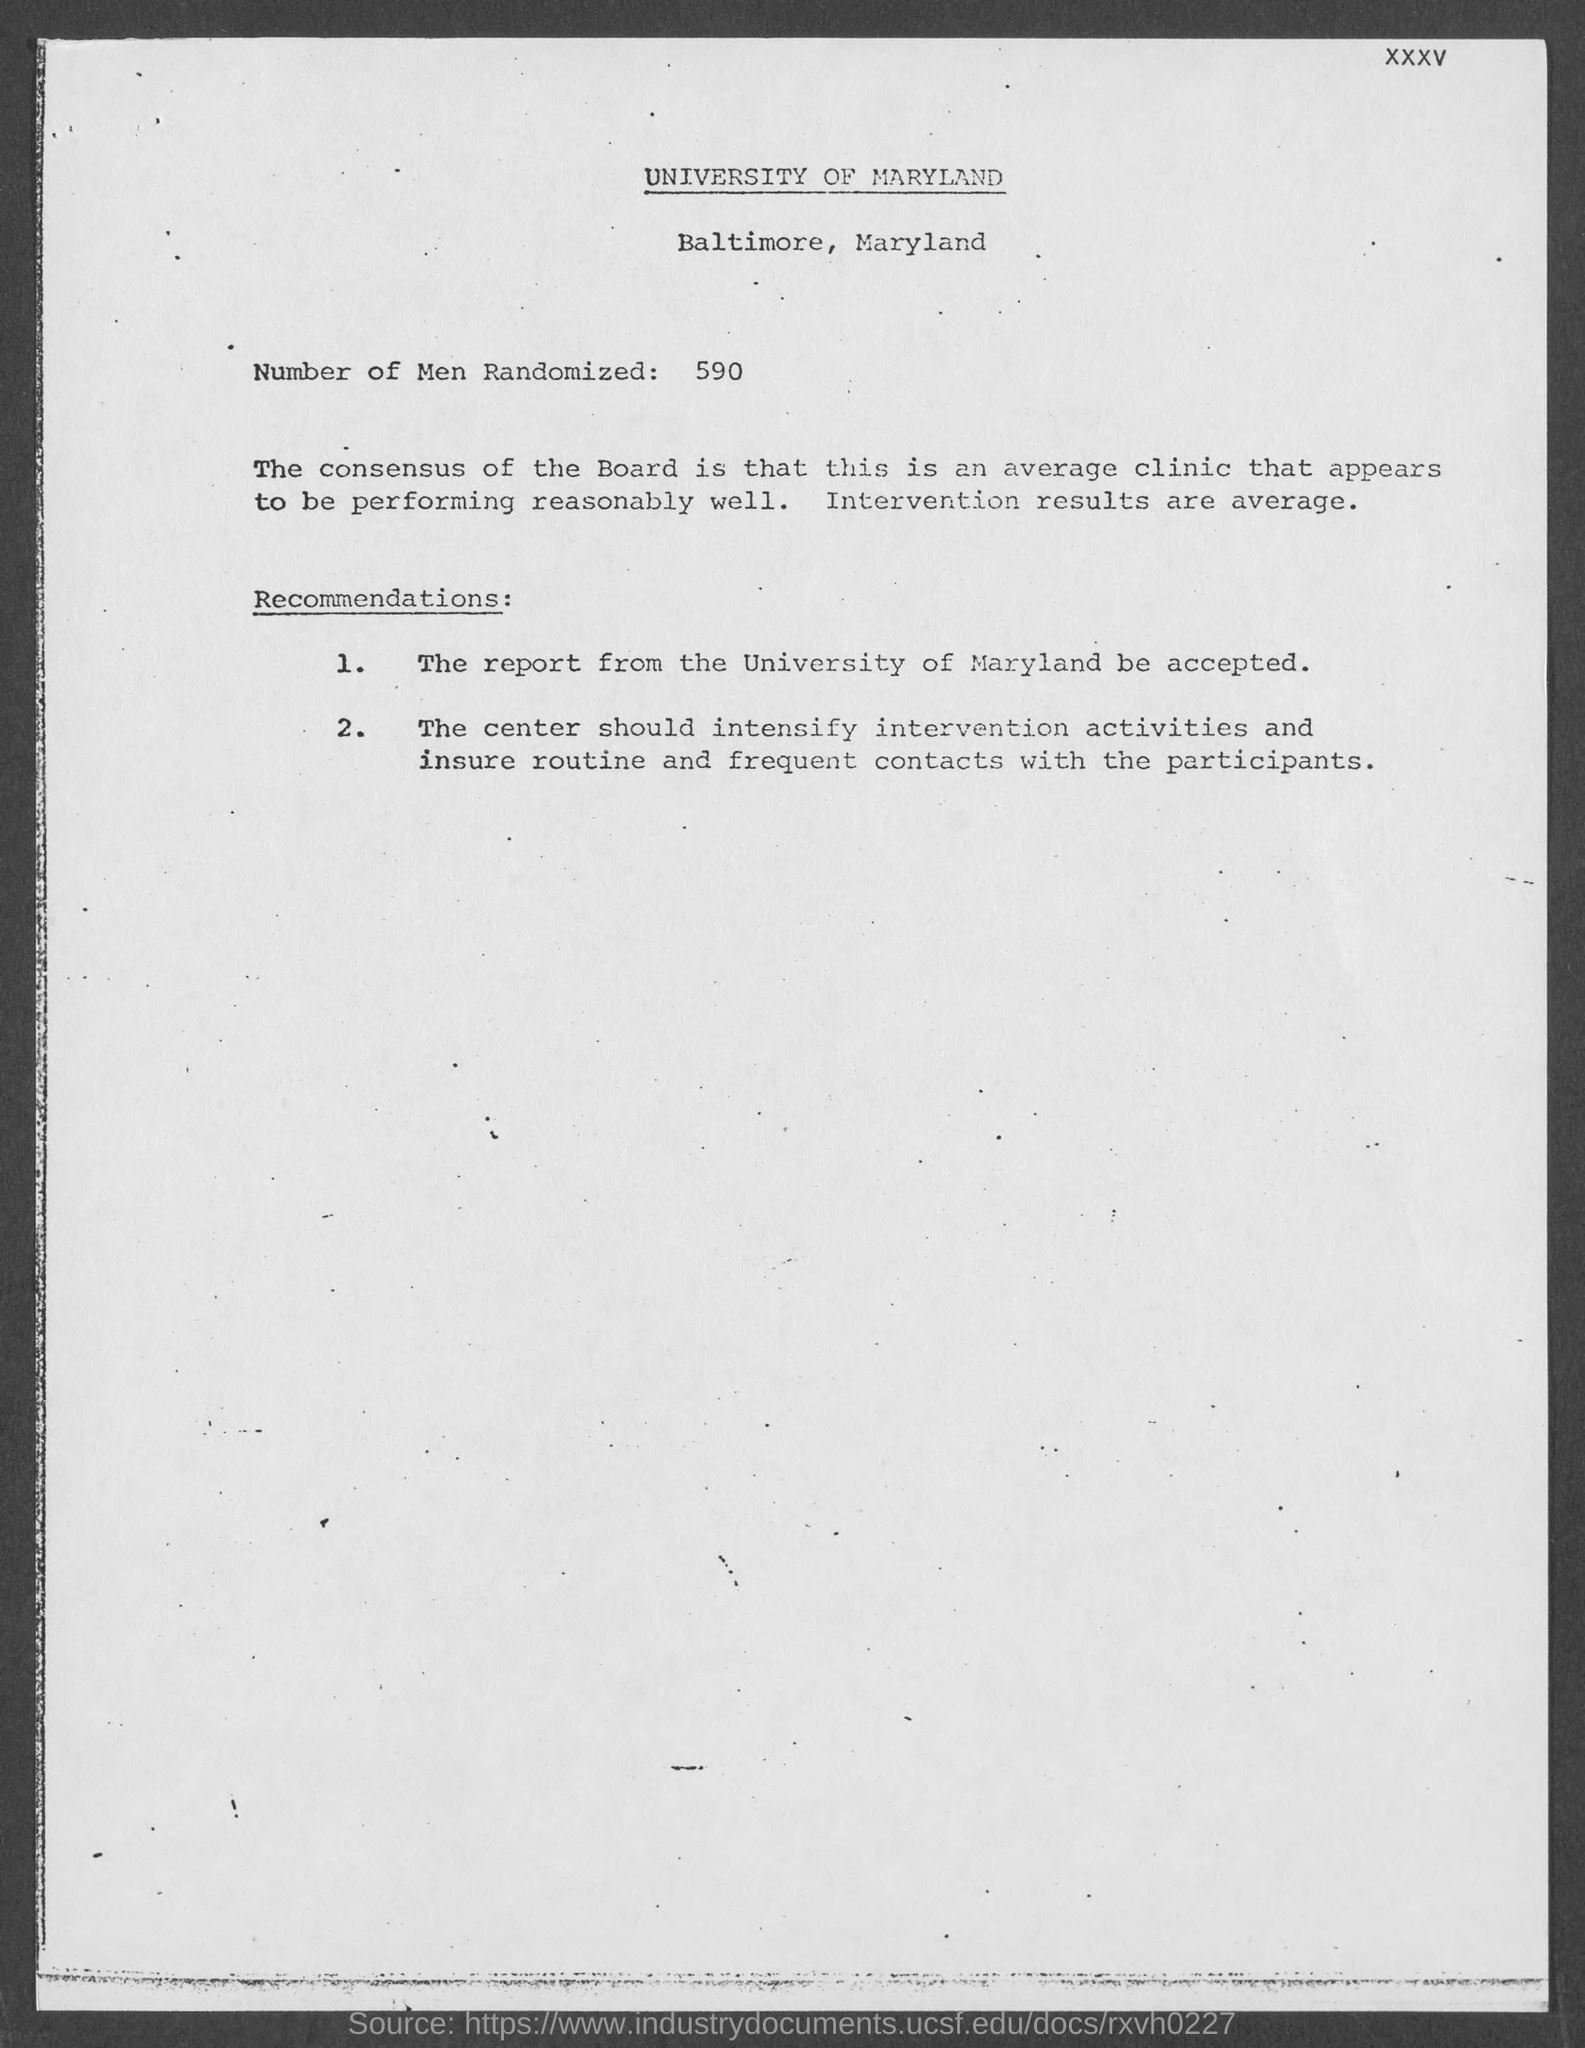Which university is mentioned in this document?
Offer a very short reply. UNIVERSITY OF MARYLAND. Where University of Maryland is located?
Provide a short and direct response. Baltimore. How many number of men randomized?
Your answer should be very brief. 590. 